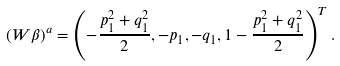<formula> <loc_0><loc_0><loc_500><loc_500>( W \beta ) ^ { a } = \left ( - \frac { p _ { 1 } ^ { 2 } + q _ { 1 } ^ { 2 } } { 2 } , - p _ { 1 } , - q _ { 1 } , 1 - \frac { p _ { 1 } ^ { 2 } + q _ { 1 } ^ { 2 } } { 2 } \right ) ^ { T } .</formula> 